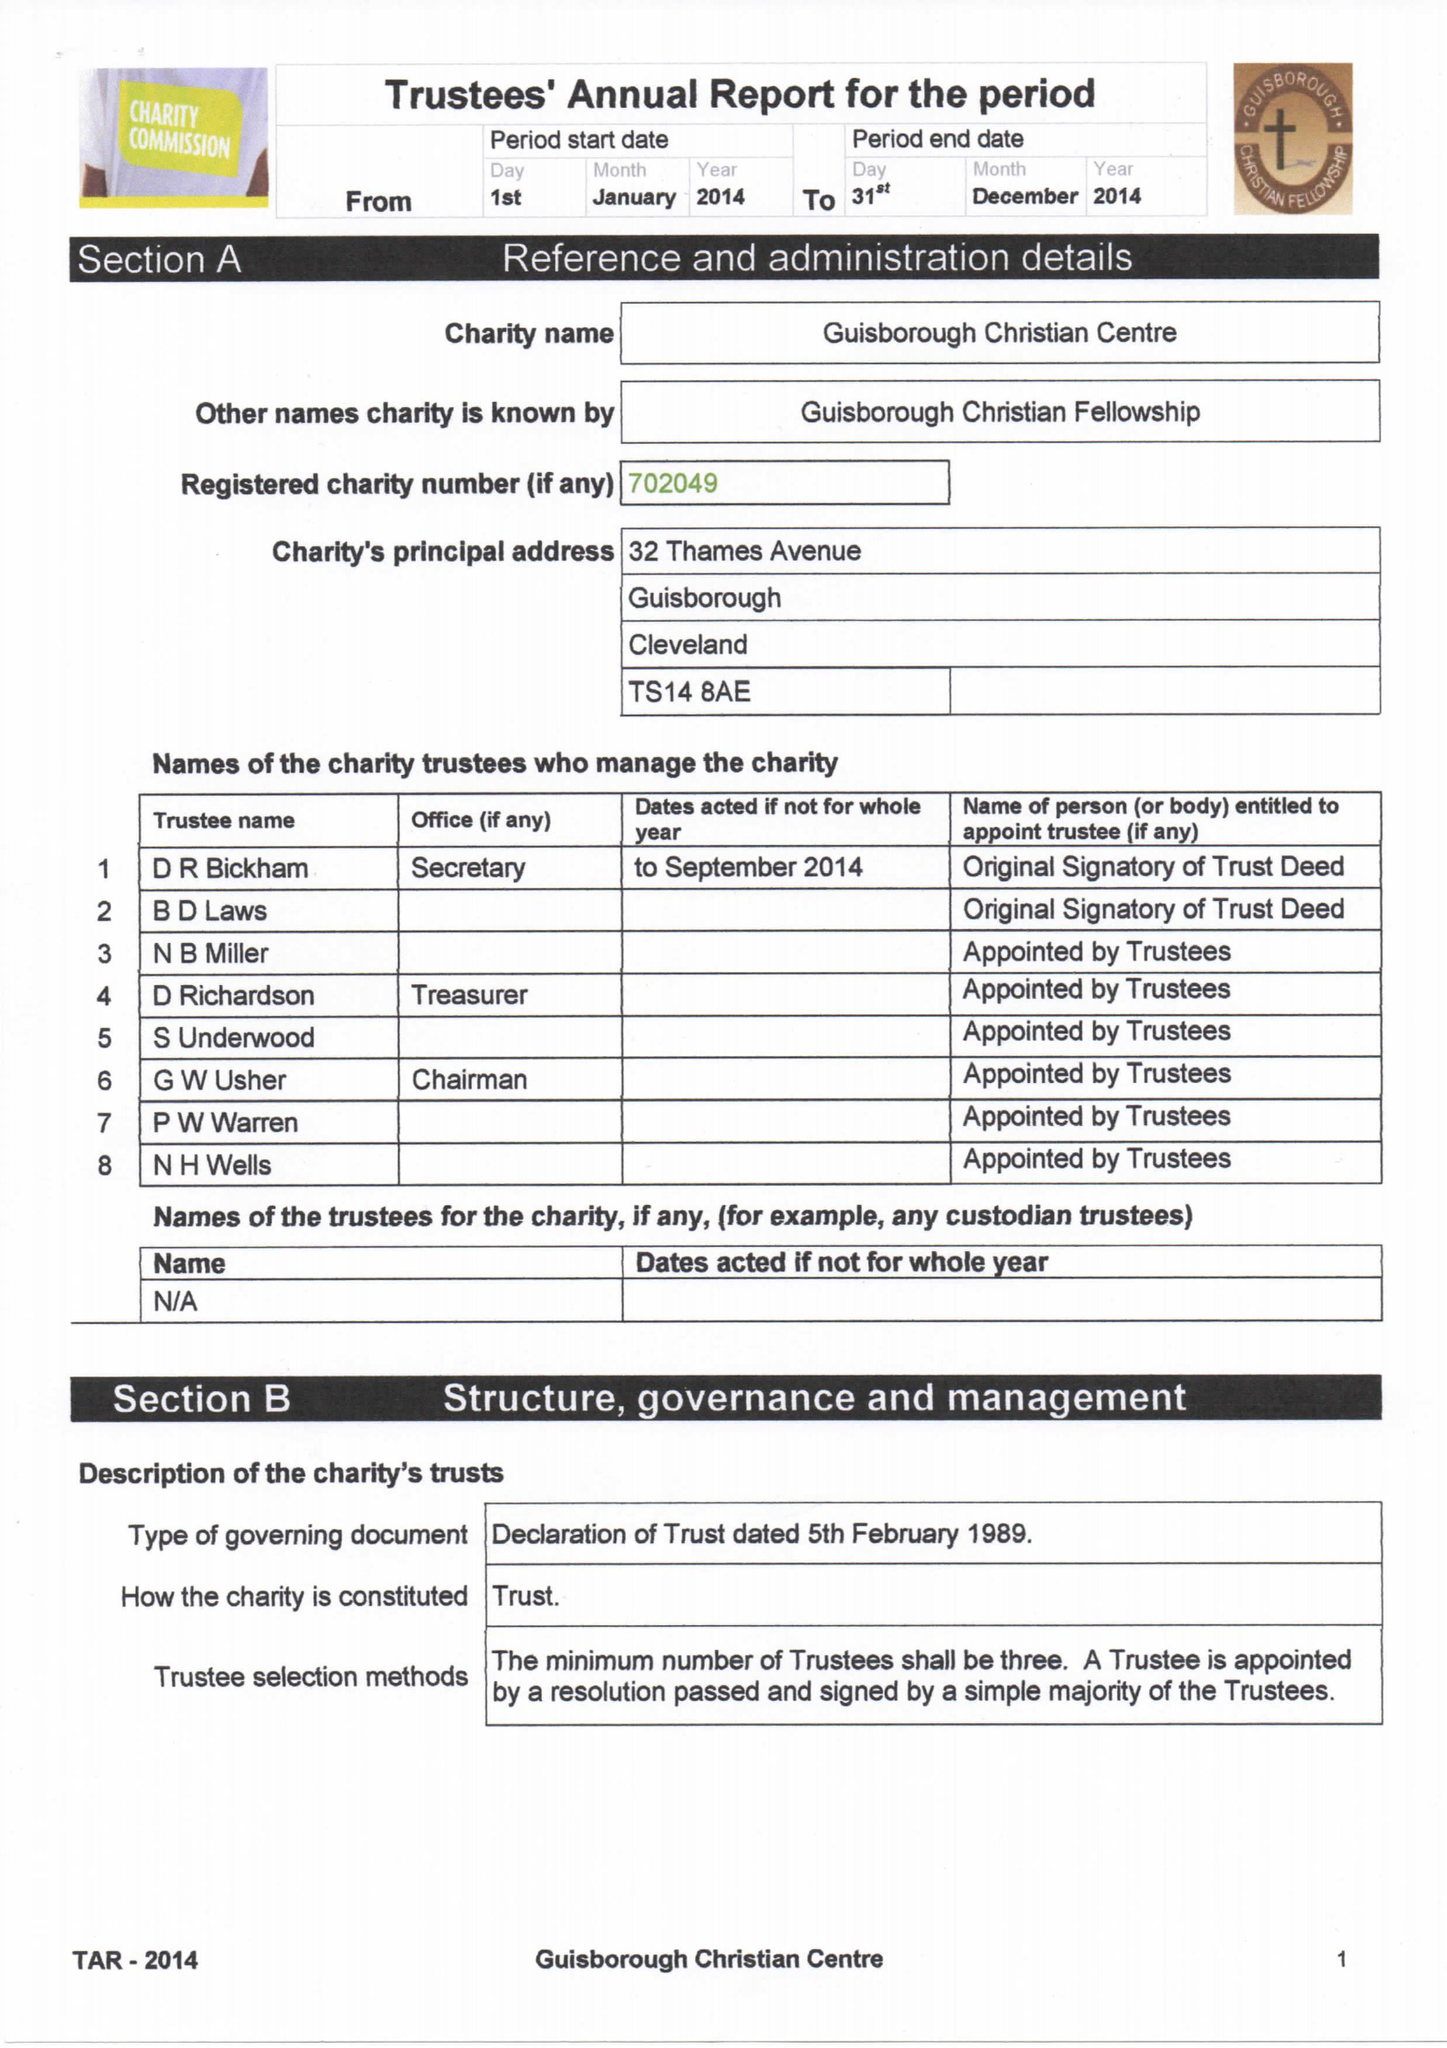What is the value for the spending_annually_in_british_pounds?
Answer the question using a single word or phrase. 28797.00 